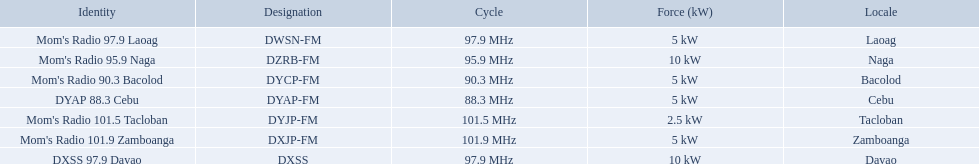Which stations use less than 10kw of power? Mom's Radio 97.9 Laoag, Mom's Radio 90.3 Bacolod, DYAP 88.3 Cebu, Mom's Radio 101.5 Tacloban, Mom's Radio 101.9 Zamboanga. Do any stations use less than 5kw of power? if so, which ones? Mom's Radio 101.5 Tacloban. What are all of the frequencies? 97.9 MHz, 95.9 MHz, 90.3 MHz, 88.3 MHz, 101.5 MHz, 101.9 MHz, 97.9 MHz. Which of these frequencies is the lowest? 88.3 MHz. Which branding does this frequency belong to? DYAP 88.3 Cebu. 